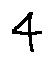Convert formula to latex. <formula><loc_0><loc_0><loc_500><loc_500>4</formula> 